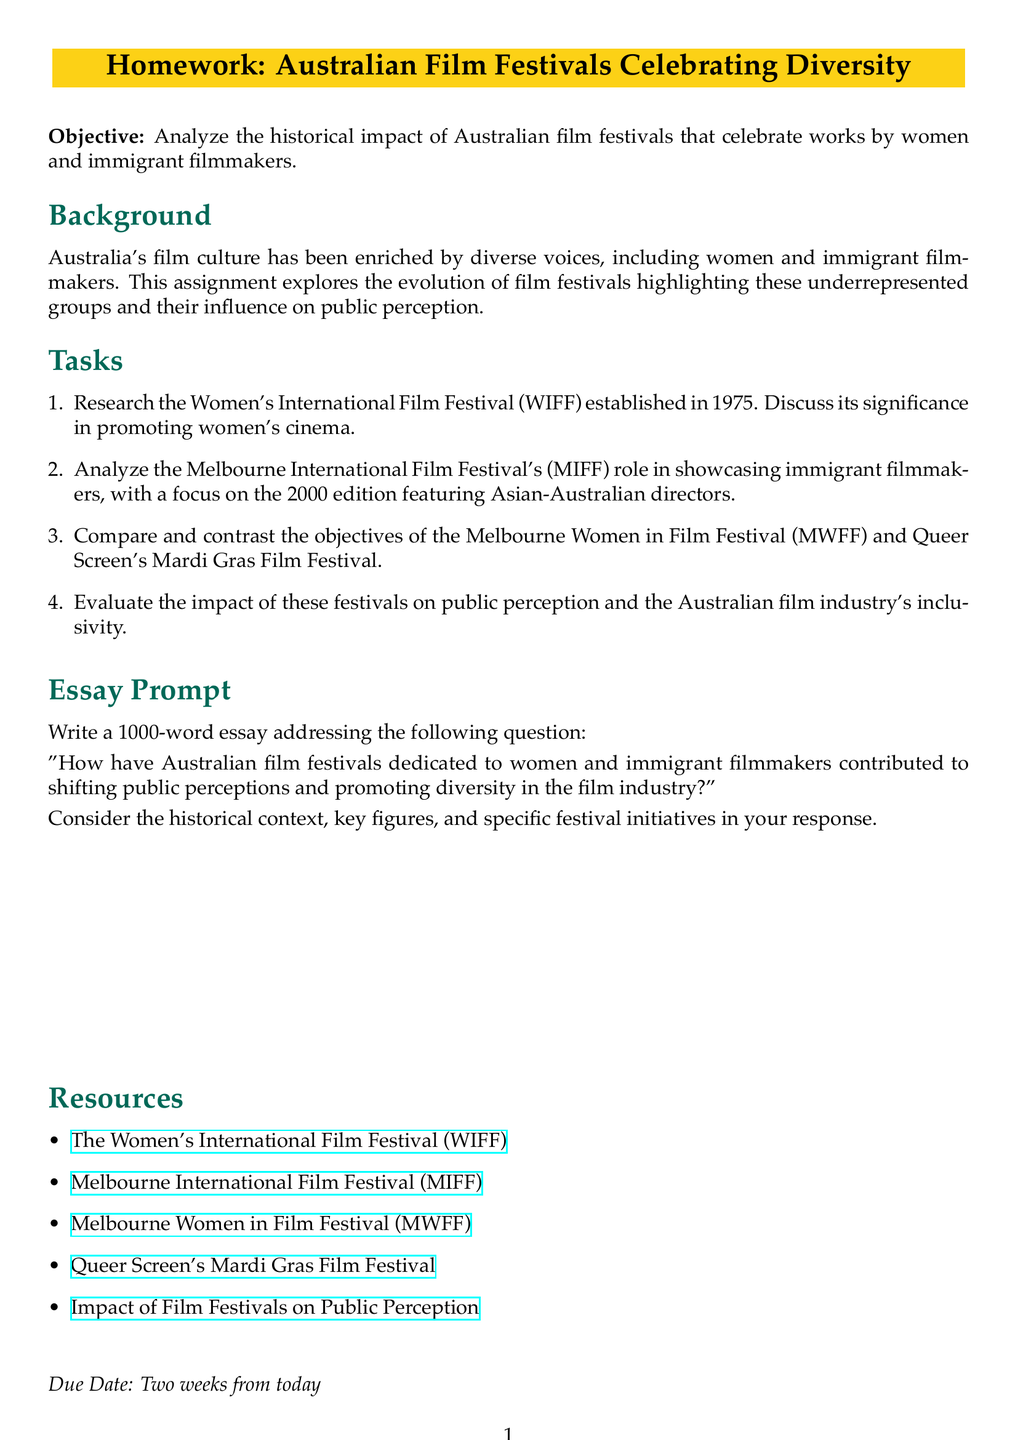What is the significance of the WIFF? The Women's International Film Festival (WIFF) established in 1975 is significant for promoting women's cinema.
Answer: promoting women's cinema In what year was the WIFF established? The established year of the Women's International Film Festival (WIFF) is stated in the document.
Answer: 1975 What does MIFF focus on in its 2000 edition? The Melbourne International Film Festival (MIFF) focused on showcasing immigrant filmmakers, specifically mentioning Asian-Australian directors in the 2000 edition.
Answer: Asian-Australian directors What are the two festivals compared in the document? The document mentions the Melbourne Women in Film Festival (MWFF) and Queer Screen's Mardi Gras Film Festival for comparison.
Answer: MWFF and Mardi Gras Film Festival What is the essay length requirement? The document specifies a word count for the essay addressing the contributions of the festivals.
Answer: 1000 words What is the objective of this homework? The objective of the homework is to analyze the impact of Australian film festivals celebrating works by women and immigrant filmmakers.
Answer: analyze the impact What type of festivals does the document talk about? The document discusses film festivals that celebrate diversity specifically in the context of women and immigrant filmmakers.
Answer: diversity festivals How long is the due date from today? The document indicates the time frame given for submission of the homework.
Answer: Two weeks 